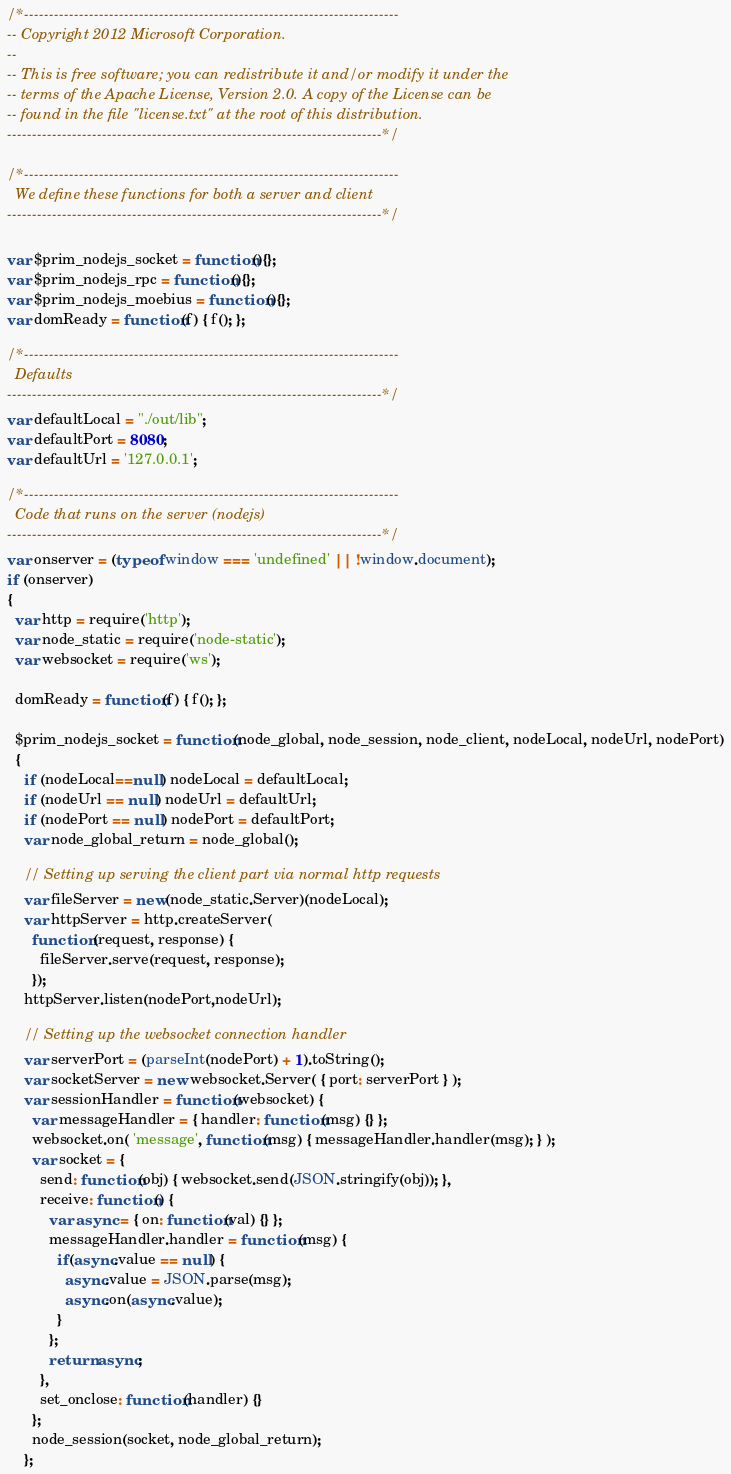<code> <loc_0><loc_0><loc_500><loc_500><_JavaScript_>/*---------------------------------------------------------------------------
-- Copyright 2012 Microsoft Corporation.
--
-- This is free software; you can redistribute it and/or modify it under the
-- terms of the Apache License, Version 2.0. A copy of the License can be
-- found in the file "license.txt" at the root of this distribution.
---------------------------------------------------------------------------*/

/*---------------------------------------------------------------------------
  We define these functions for both a server and client
---------------------------------------------------------------------------*/

var $prim_nodejs_socket = function(){};
var $prim_nodejs_rpc = function(){};
var $prim_nodejs_moebius = function(){};
var domReady = function(f) { f(); };

/*---------------------------------------------------------------------------
  Defaults
---------------------------------------------------------------------------*/
var defaultLocal = "./out/lib";
var defaultPort = 8080;
var defaultUrl = '127.0.0.1';

/*---------------------------------------------------------------------------
  Code that runs on the server (nodejs)
---------------------------------------------------------------------------*/
var onserver = (typeof window === 'undefined' || !window.document);
if (onserver) 
{
  var http = require('http');
  var node_static = require('node-static');
  var websocket = require('ws');

  domReady = function(f) { f(); };

  $prim_nodejs_socket = function(node_global, node_session, node_client, nodeLocal, nodeUrl, nodePort)
  { 
    if (nodeLocal==null) nodeLocal = defaultLocal;
    if (nodeUrl == null) nodeUrl = defaultUrl;
    if (nodePort == null) nodePort = defaultPort;
    var node_global_return = node_global();

    // Setting up serving the client part via normal http requests
    var fileServer = new(node_static.Server)(nodeLocal);
    var httpServer = http.createServer( 
      function (request, response) {
        fileServer.serve(request, response);
      });
    httpServer.listen(nodePort,nodeUrl);

    // Setting up the websocket connection handler
    var serverPort = (parseInt(nodePort) + 1).toString();
    var socketServer = new websocket.Server( { port: serverPort } );
    var sessionHandler = function(websocket) {
      var messageHandler = { handler: function(msg) {} };
      websocket.on( 'message', function(msg) { messageHandler.handler(msg); } );
      var socket = { 
        send: function(obj) { websocket.send(JSON.stringify(obj)); },
        receive: function() { 
          var async = { on: function(val) {} };
          messageHandler.handler = function(msg) {
            if(async.value == null) {
              async.value = JSON.parse(msg);
              async.on(async.value);
            } 
          };
          return async;
        },
        set_onclose: function(handler) {}
      };
      node_session(socket, node_global_return);
    };</code> 